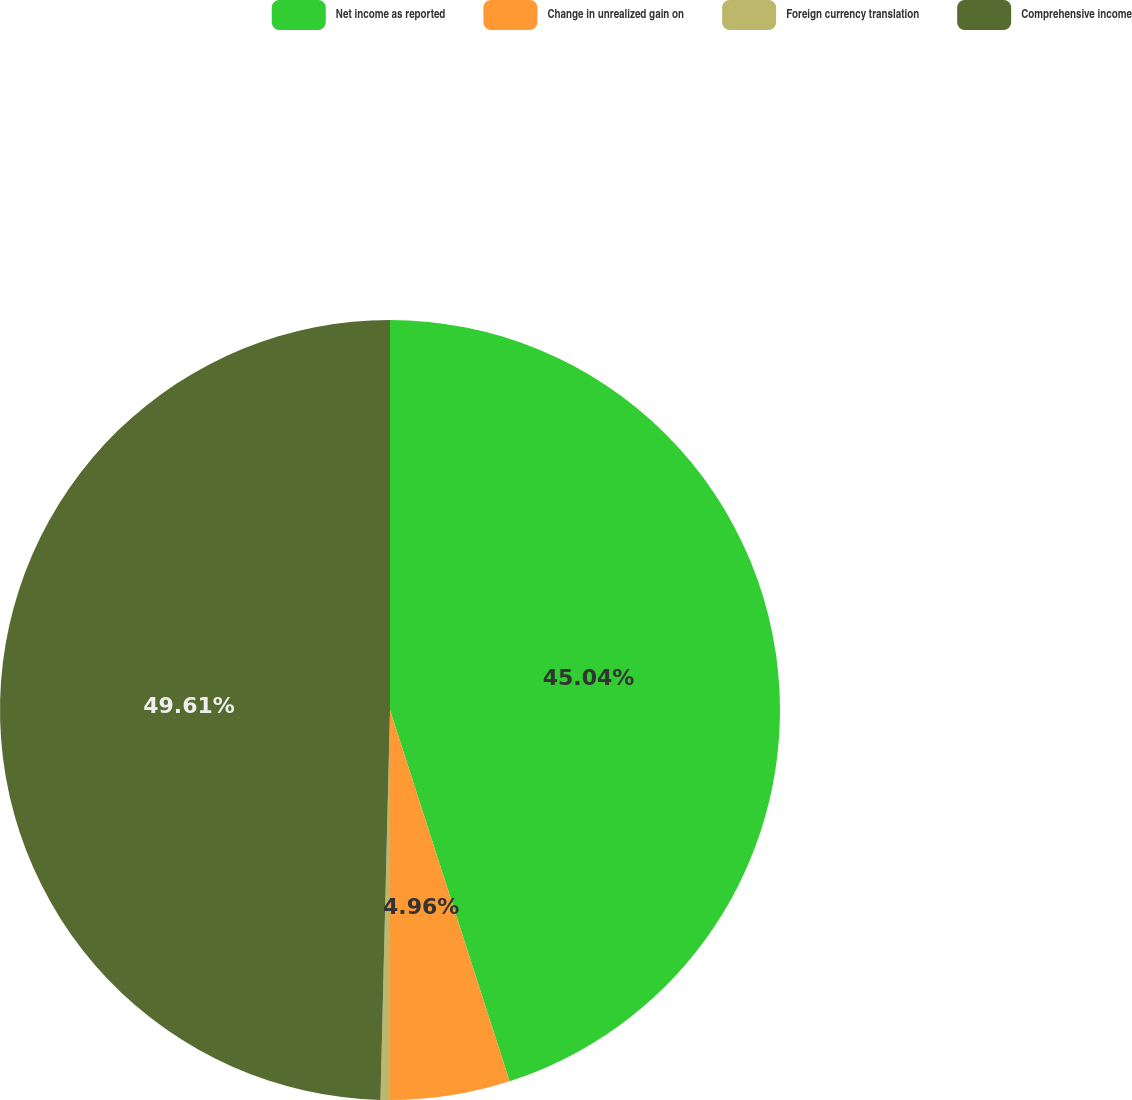Convert chart. <chart><loc_0><loc_0><loc_500><loc_500><pie_chart><fcel>Net income as reported<fcel>Change in unrealized gain on<fcel>Foreign currency translation<fcel>Comprehensive income<nl><fcel>45.04%<fcel>4.96%<fcel>0.39%<fcel>49.61%<nl></chart> 